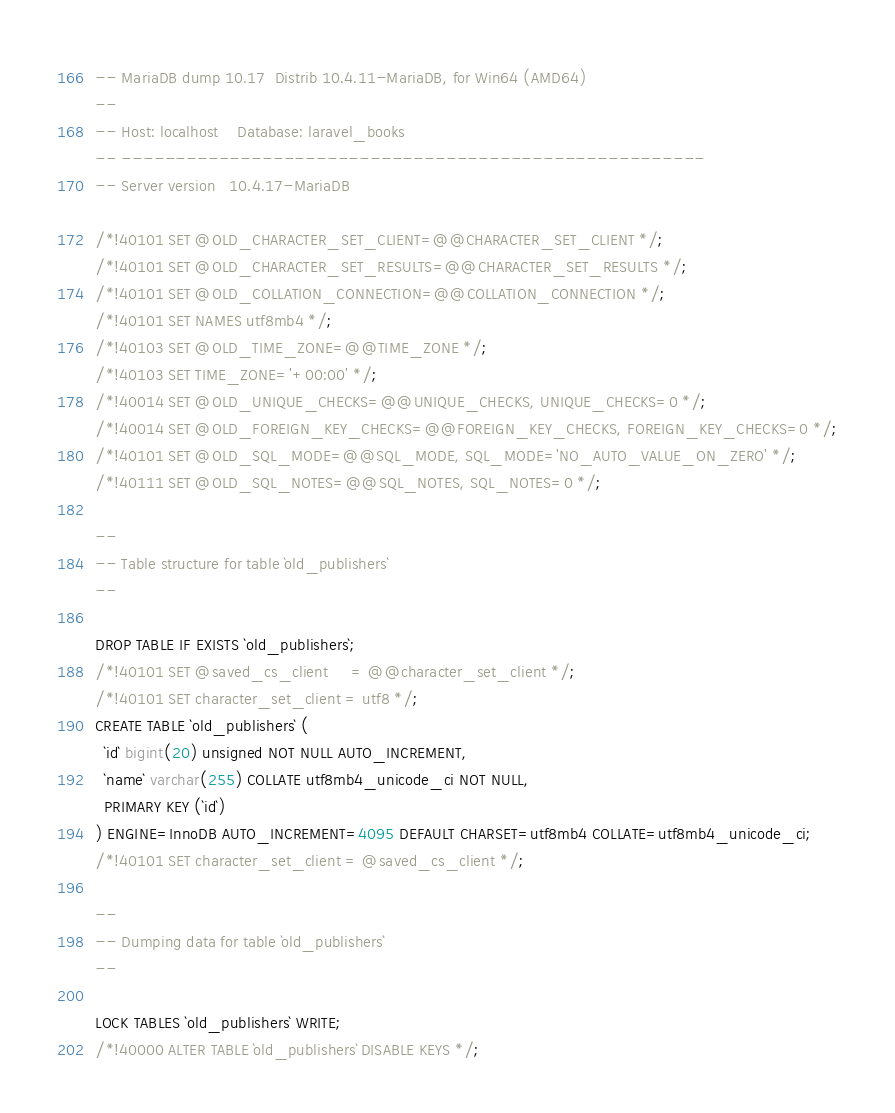<code> <loc_0><loc_0><loc_500><loc_500><_SQL_>-- MariaDB dump 10.17  Distrib 10.4.11-MariaDB, for Win64 (AMD64)
--
-- Host: localhost    Database: laravel_books
-- ------------------------------------------------------
-- Server version	10.4.17-MariaDB

/*!40101 SET @OLD_CHARACTER_SET_CLIENT=@@CHARACTER_SET_CLIENT */;
/*!40101 SET @OLD_CHARACTER_SET_RESULTS=@@CHARACTER_SET_RESULTS */;
/*!40101 SET @OLD_COLLATION_CONNECTION=@@COLLATION_CONNECTION */;
/*!40101 SET NAMES utf8mb4 */;
/*!40103 SET @OLD_TIME_ZONE=@@TIME_ZONE */;
/*!40103 SET TIME_ZONE='+00:00' */;
/*!40014 SET @OLD_UNIQUE_CHECKS=@@UNIQUE_CHECKS, UNIQUE_CHECKS=0 */;
/*!40014 SET @OLD_FOREIGN_KEY_CHECKS=@@FOREIGN_KEY_CHECKS, FOREIGN_KEY_CHECKS=0 */;
/*!40101 SET @OLD_SQL_MODE=@@SQL_MODE, SQL_MODE='NO_AUTO_VALUE_ON_ZERO' */;
/*!40111 SET @OLD_SQL_NOTES=@@SQL_NOTES, SQL_NOTES=0 */;

--
-- Table structure for table `old_publishers`
--

DROP TABLE IF EXISTS `old_publishers`;
/*!40101 SET @saved_cs_client     = @@character_set_client */;
/*!40101 SET character_set_client = utf8 */;
CREATE TABLE `old_publishers` (
  `id` bigint(20) unsigned NOT NULL AUTO_INCREMENT,
  `name` varchar(255) COLLATE utf8mb4_unicode_ci NOT NULL,
  PRIMARY KEY (`id`)
) ENGINE=InnoDB AUTO_INCREMENT=4095 DEFAULT CHARSET=utf8mb4 COLLATE=utf8mb4_unicode_ci;
/*!40101 SET character_set_client = @saved_cs_client */;

--
-- Dumping data for table `old_publishers`
--

LOCK TABLES `old_publishers` WRITE;
/*!40000 ALTER TABLE `old_publishers` DISABLE KEYS */;</code> 